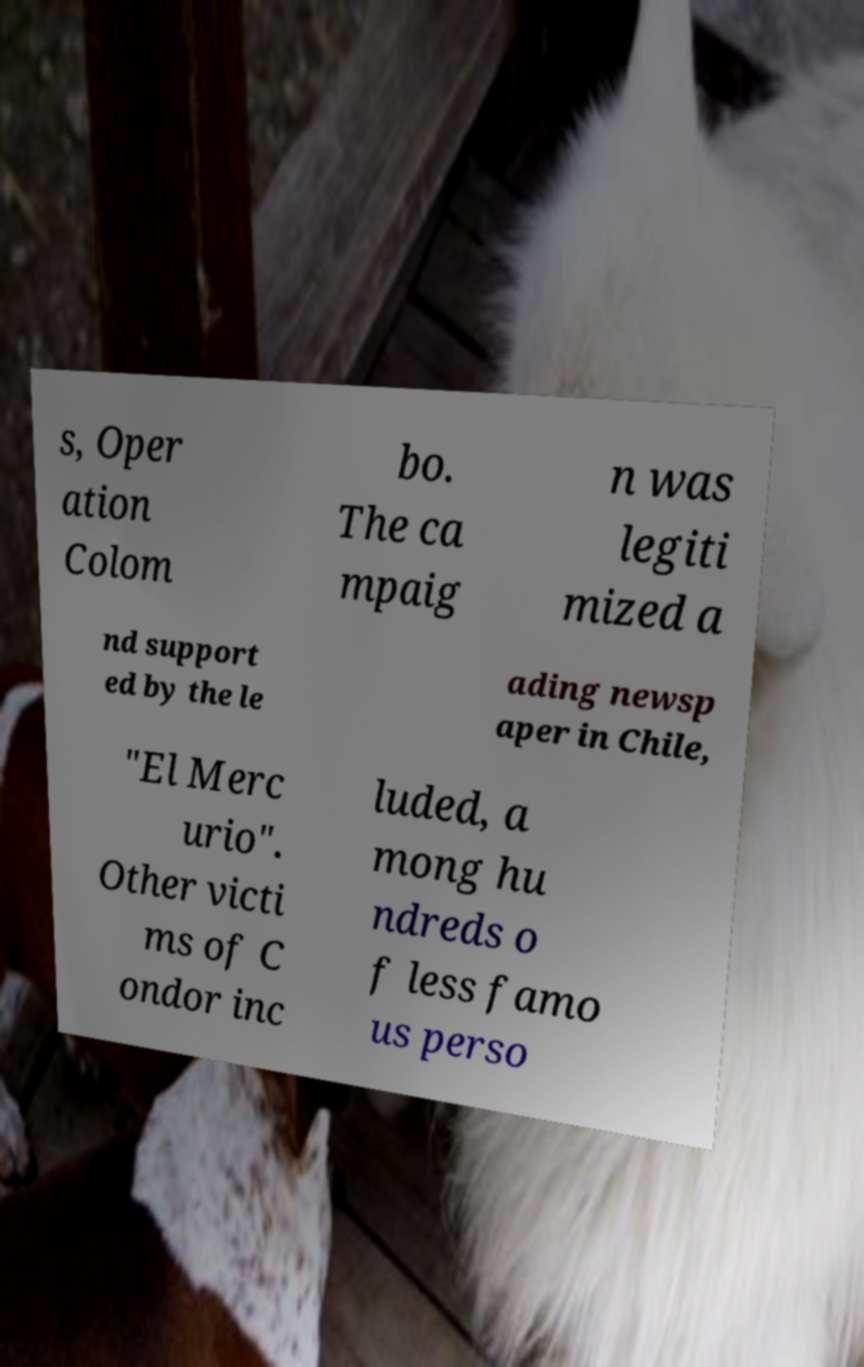Please identify and transcribe the text found in this image. s, Oper ation Colom bo. The ca mpaig n was legiti mized a nd support ed by the le ading newsp aper in Chile, "El Merc urio". Other victi ms of C ondor inc luded, a mong hu ndreds o f less famo us perso 